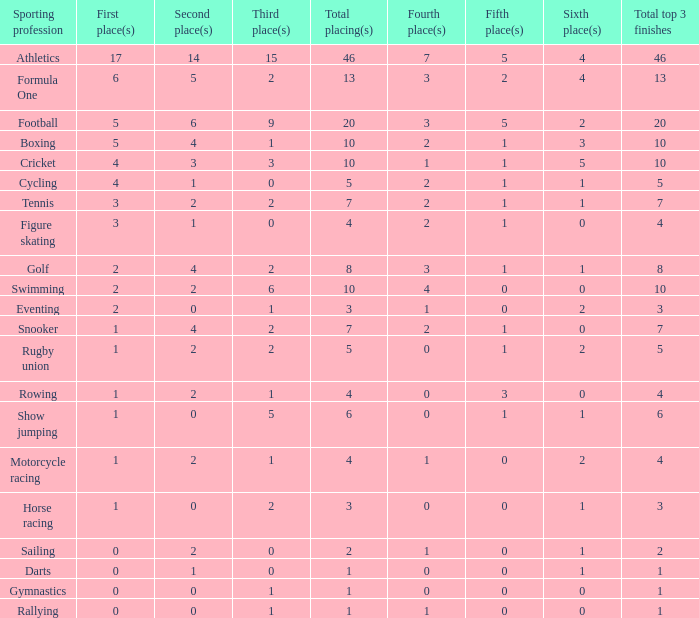How many second place showings does snooker have? 4.0. 